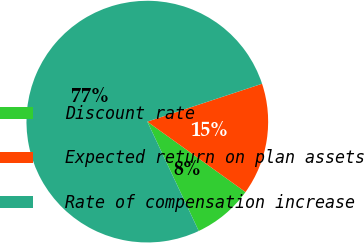Convert chart to OTSL. <chart><loc_0><loc_0><loc_500><loc_500><pie_chart><fcel>Discount rate<fcel>Expected return on plan assets<fcel>Rate of compensation increase<nl><fcel>8.1%<fcel>14.98%<fcel>76.92%<nl></chart> 